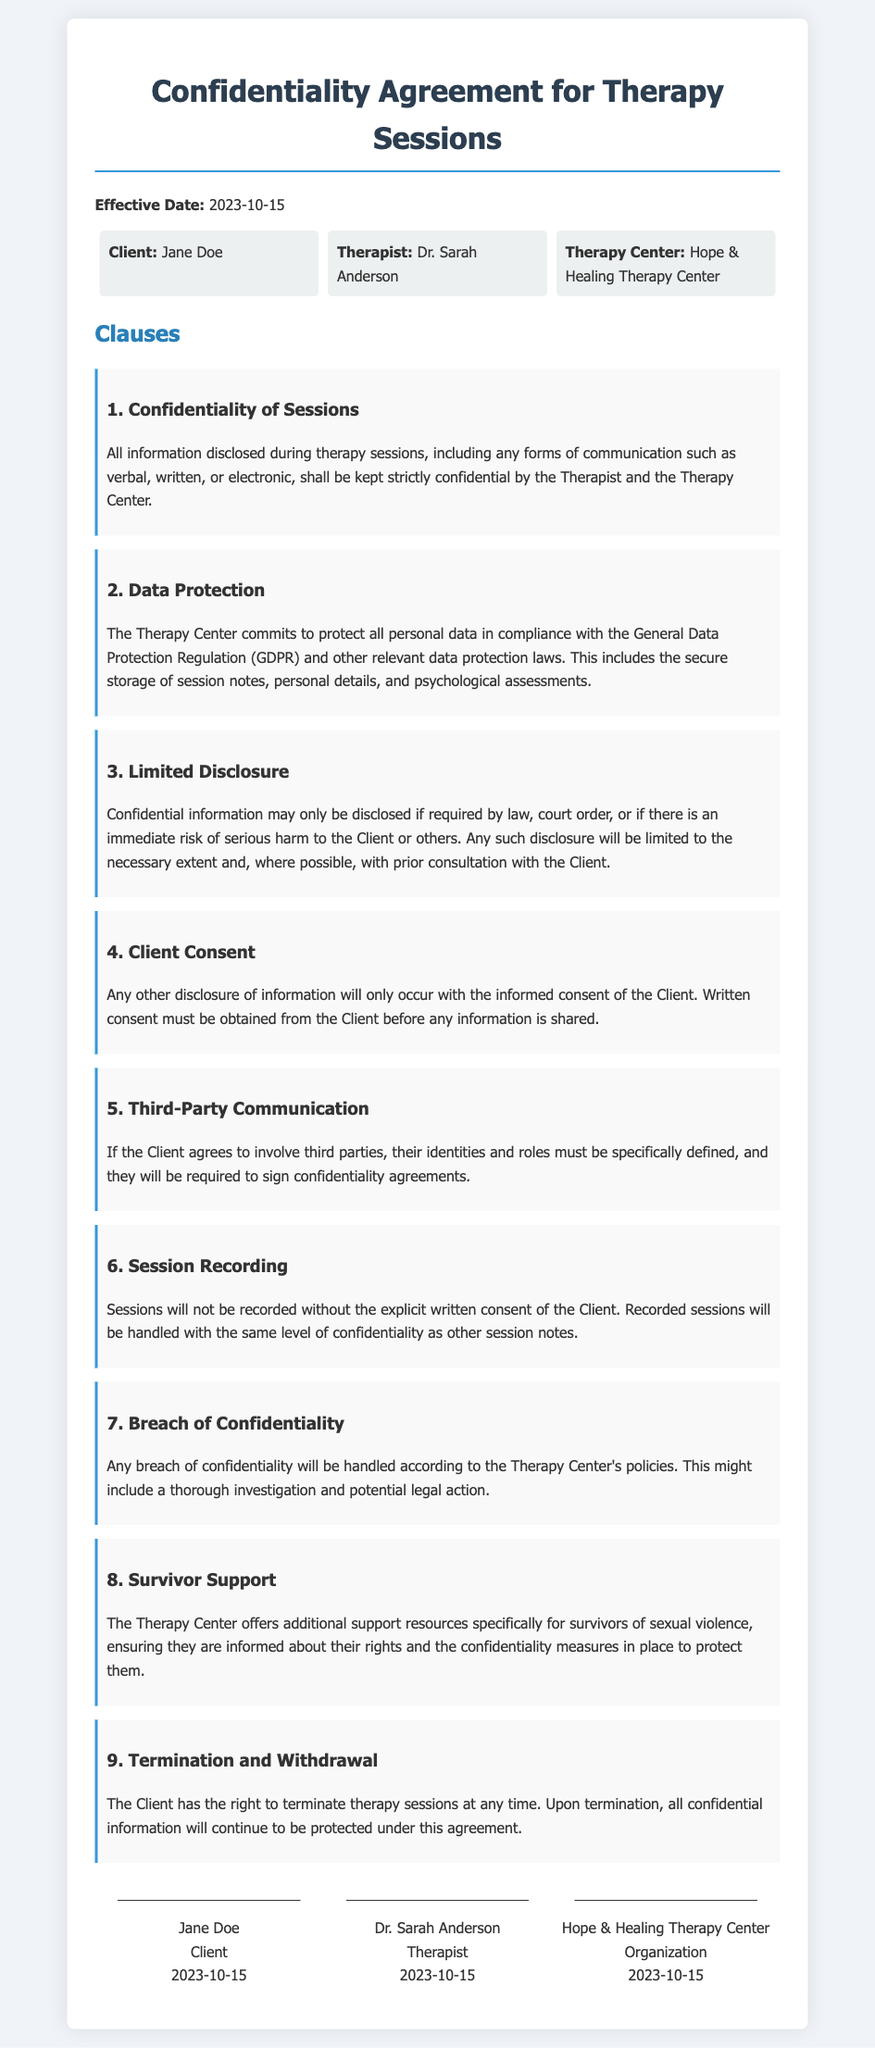What is the effective date of the agreement? The effective date can be found in the introduction section of the document near the top.
Answer: 2023-10-15 Who is the therapist? This information is listed in the section identifying the parties involved in the agreement.
Answer: Dr. Sarah Anderson What clause addresses session recording? The clause number refers to the specific regulation within the document for session recording practices.
Answer: 6 What must be obtained before sharing any confidential information? This detail is specified in the clause regarding consent required for disclosing information.
Answer: Written consent What does the Therapy Center commit to protect? The agreement outlines the data protection obligations of the Therapy Center in compliance with specific regulations.
Answer: Personal data 